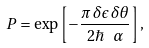<formula> <loc_0><loc_0><loc_500><loc_500>P = \exp \left [ - \frac { \pi \, \delta \epsilon \, \delta \theta } { 2 \hbar { \, } \ \alpha } \right ] ,</formula> 